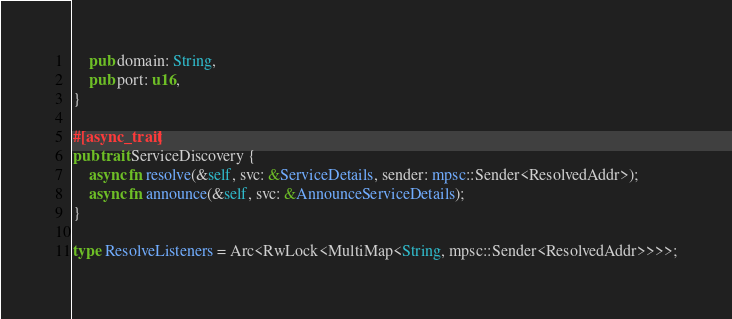<code> <loc_0><loc_0><loc_500><loc_500><_Rust_>    pub domain: String,
    pub port: u16,
}

#[async_trait]
pub trait ServiceDiscovery {
    async fn resolve(&self, svc: &ServiceDetails, sender: mpsc::Sender<ResolvedAddr>);
    async fn announce(&self, svc: &AnnounceServiceDetails);
}

type ResolveListeners = Arc<RwLock<MultiMap<String, mpsc::Sender<ResolvedAddr>>>>;
</code> 